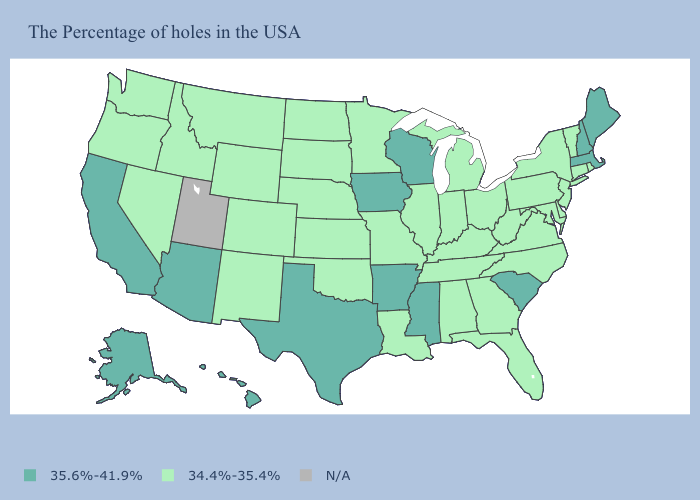Which states have the highest value in the USA?
Write a very short answer. Maine, Massachusetts, New Hampshire, South Carolina, Wisconsin, Mississippi, Arkansas, Iowa, Texas, Arizona, California, Alaska, Hawaii. Name the states that have a value in the range N/A?
Concise answer only. Utah. What is the highest value in the West ?
Quick response, please. 35.6%-41.9%. What is the value of Utah?
Give a very brief answer. N/A. Does the first symbol in the legend represent the smallest category?
Concise answer only. No. What is the value of Mississippi?
Quick response, please. 35.6%-41.9%. What is the value of South Carolina?
Quick response, please. 35.6%-41.9%. Does Wisconsin have the highest value in the USA?
Be succinct. Yes. What is the value of Oregon?
Short answer required. 34.4%-35.4%. Does Arizona have the highest value in the USA?
Keep it brief. Yes. Name the states that have a value in the range N/A?
Quick response, please. Utah. What is the lowest value in the USA?
Be succinct. 34.4%-35.4%. What is the highest value in states that border Wisconsin?
Write a very short answer. 35.6%-41.9%. What is the lowest value in the MidWest?
Write a very short answer. 34.4%-35.4%. Does Wyoming have the lowest value in the USA?
Answer briefly. Yes. 